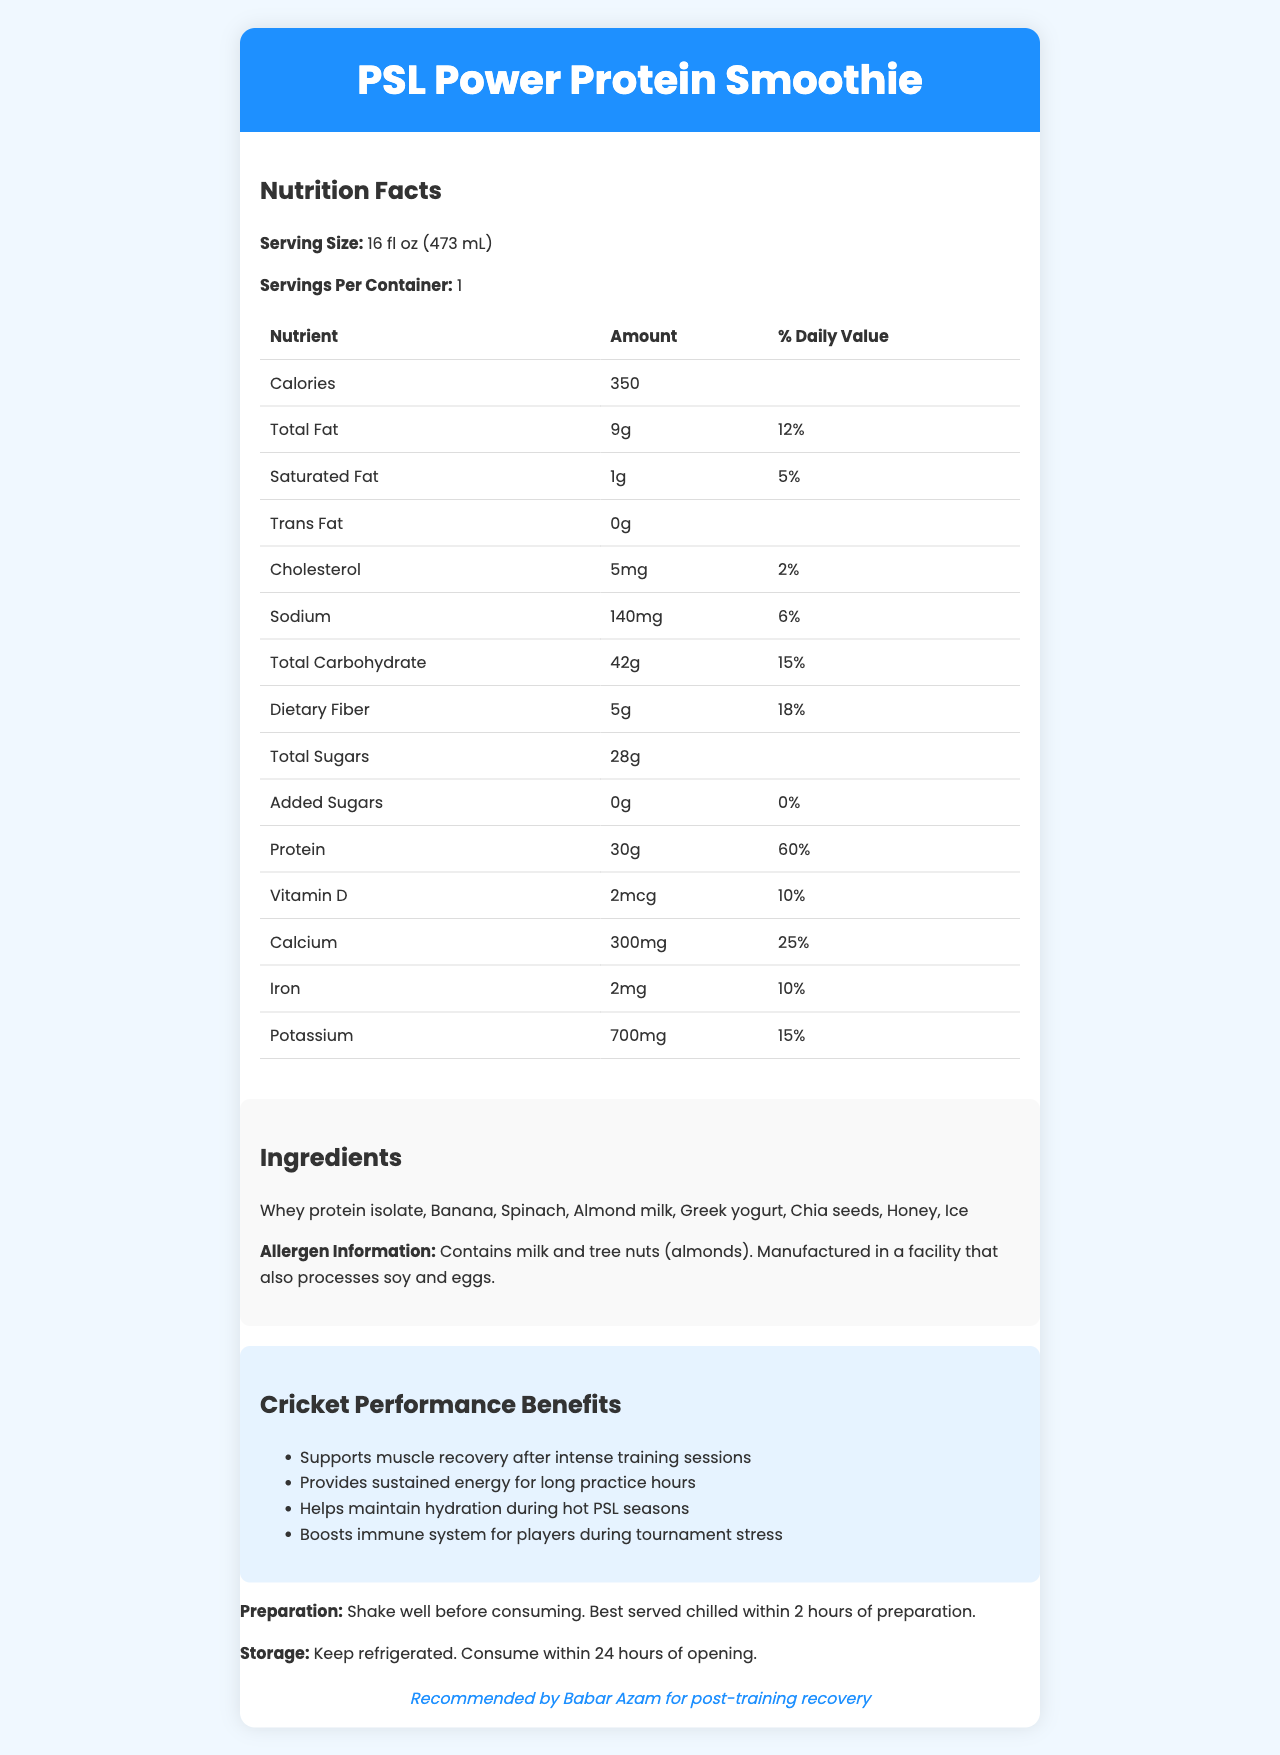what is the serving size of the PSL Power Protein Smoothie? The serving size is listed as "16 fl oz (473 mL)" in the document.
Answer: 16 fl oz (473 mL) how many calories are in one serving of the PSL Power Protein Smoothie? The document states that one serving contains 350 calories.
Answer: 350 calories what is the total amount of protein per serving? The document specifies that there are 30 grams of protein per serving.
Answer: 30g how much dietary fiber does the smoothie provide? The document shows that the dietary fiber content is 5 grams per serving.
Answer: 5g what are the main ingredients of the PSL Power Protein Smoothie? The ingredients are listed in the document under the "Ingredients" section.
Answer: Whey protein isolate, Banana, Spinach, Almond milk, Greek yogurt, Chia seeds, Honey, Ice which PSL player endorses the PSL Power Protein Smoothie? The document mentions that the smoothie is recommended by Babar Azam for post-training recovery.
Answer: Babar Azam what allergens are present in the PSL Power Protein Smoothie? A. Peanuts and Soy B. Milk and Tree Nuts C. Gluten and Shellfish D. Wheat and Eggs The document specifies that the smoothie contains milk and tree nuts (almonds).
Answer: B how many grams of total sugars does the smoothie contain? The total sugars are listed as 28 grams in the document.
Answer: 28g which of the following benefits does the PSL Power Protein Smoothie provide to cricket players? I. Supports muscle recovery II. Provides sustained energy III. Boosts immune system IV. Enhances speed A. I, II, IV B. II, III, IV C. I, III, IV D. I, II, III The document lists the benefits as supporting muscle recovery, providing sustained energy, and boosting the immune system.
Answer: D does the PSL Power Protein Smoothie contain any added sugars? The document shows that the amount of added sugars is 0 grams, indicating that there are no added sugars.
Answer: No is the smoothie recommended to be consumed immediately after preparation? The document advises that the smoothie is best served chilled within 2 hours of preparation.
Answer: Yes how should the smoothie be stored? The document provides these storage instructions to maintain the smoothie’s quality.
Answer: Keep refrigerated and consume within 24 hours of opening summarize the main nutritional attributes and benefits of the PSL Power Protein Smoothie for cricket players. The document highlights essential nutritional details and several performance benefits tailored specifically for cricket players. The smoothie supports muscle recovery, supplies long-lasting energy, helps in hydration, and aids the immune system.
Answer: The PSL Power Protein Smoothie is a high-protein drink that contains 350 calories per serving, with 30g of protein, 5g of dietary fiber, and 28g of total sugars. It is low in saturated fat and cholesterol and is rich in important nutrients like calcium, iron, and potassium. Endorsed by Babar Azam, it supports muscle recovery, provides sustained energy, maintains hydration, and boosts the immune system, making it an excellent post-training recovery drink for cricket players. what is the manufacturing facility's potential cross-contamination risk? The document mentions that the smoothie is manufactured in a facility that processes soy and eggs, but it does not provide specific details on the measures taken to prevent cross-contamination.
Answer: Not enough information 